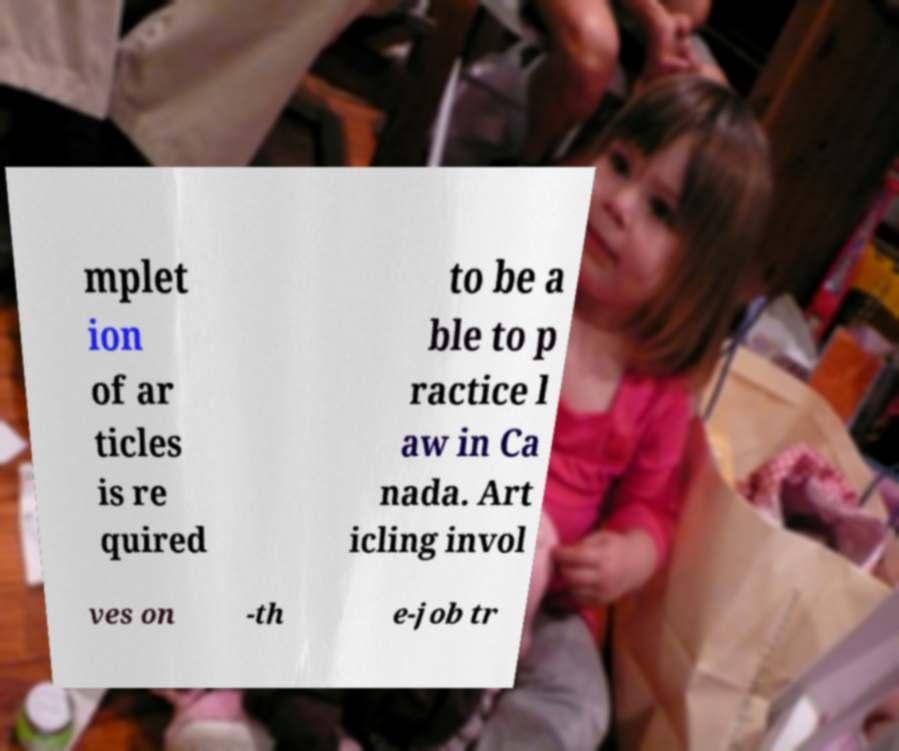I need the written content from this picture converted into text. Can you do that? mplet ion of ar ticles is re quired to be a ble to p ractice l aw in Ca nada. Art icling invol ves on -th e-job tr 